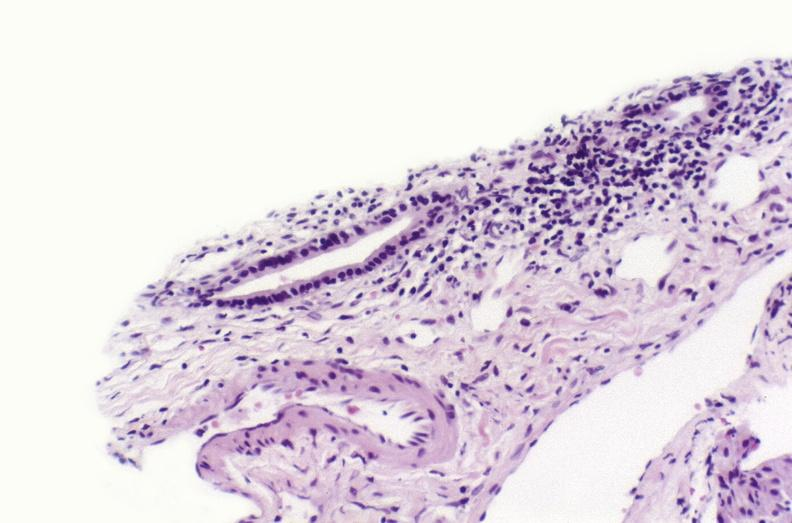s section of spleen through hilum present?
Answer the question using a single word or phrase. No 